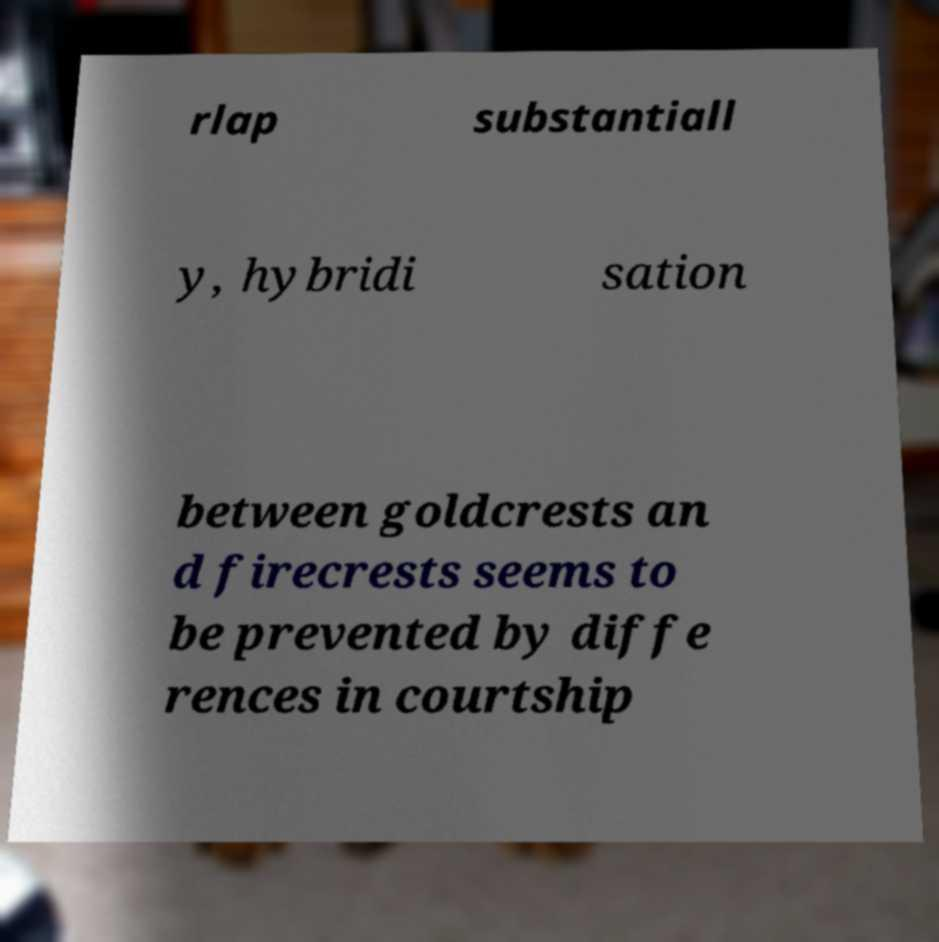For documentation purposes, I need the text within this image transcribed. Could you provide that? rlap substantiall y, hybridi sation between goldcrests an d firecrests seems to be prevented by diffe rences in courtship 